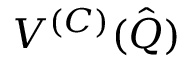Convert formula to latex. <formula><loc_0><loc_0><loc_500><loc_500>V ^ { ( C ) } ( \hat { Q } )</formula> 